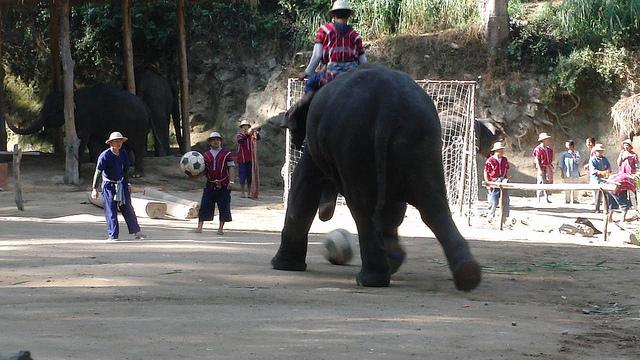What is the elephant doing with the ball? Please explain your reasoning. kicking it. An elephant is walking down the street with a soccer ball near its feet. 